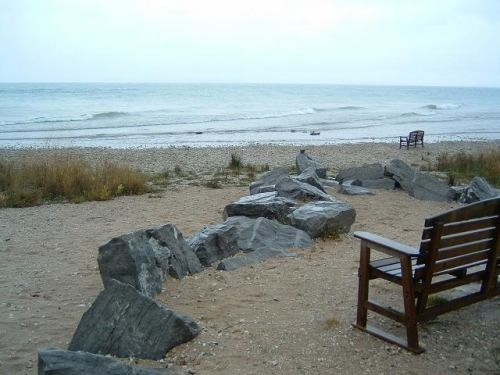Describe the objects in this image and their specific colors. I can see bench in lightblue, black, gray, and darkgray tones and bench in lightblue, gray, and black tones in this image. 